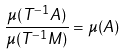<formula> <loc_0><loc_0><loc_500><loc_500>\frac { \mu ( T ^ { - 1 } A ) } { \mu ( T ^ { - 1 } M ) } = \mu ( A )</formula> 